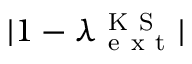Convert formula to latex. <formula><loc_0><loc_0><loc_500><loc_500>| 1 - \lambda _ { e x t } ^ { K S } |</formula> 